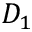<formula> <loc_0><loc_0><loc_500><loc_500>D _ { 1 }</formula> 